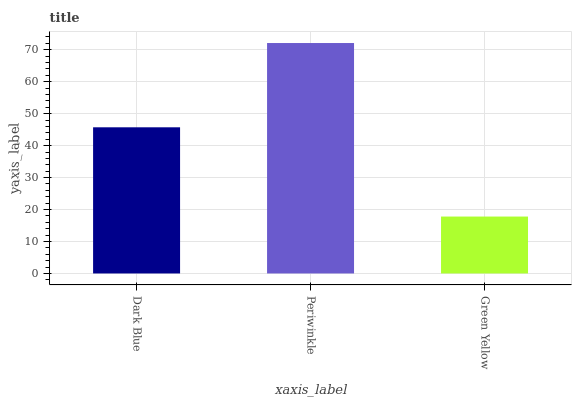Is Green Yellow the minimum?
Answer yes or no. Yes. Is Periwinkle the maximum?
Answer yes or no. Yes. Is Periwinkle the minimum?
Answer yes or no. No. Is Green Yellow the maximum?
Answer yes or no. No. Is Periwinkle greater than Green Yellow?
Answer yes or no. Yes. Is Green Yellow less than Periwinkle?
Answer yes or no. Yes. Is Green Yellow greater than Periwinkle?
Answer yes or no. No. Is Periwinkle less than Green Yellow?
Answer yes or no. No. Is Dark Blue the high median?
Answer yes or no. Yes. Is Dark Blue the low median?
Answer yes or no. Yes. Is Green Yellow the high median?
Answer yes or no. No. Is Periwinkle the low median?
Answer yes or no. No. 